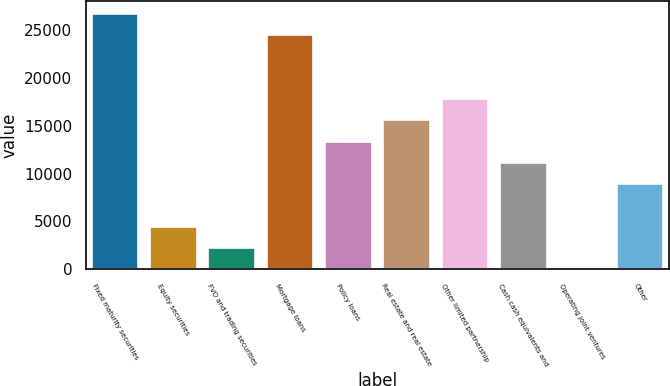<chart> <loc_0><loc_0><loc_500><loc_500><bar_chart><fcel>Fixed maturity securities<fcel>Equity securities<fcel>FVO and trading securities<fcel>Mortgage loans<fcel>Policy loans<fcel>Real estate and real estate<fcel>Other limited partnership<fcel>Cash cash equivalents and<fcel>Operating joint ventures<fcel>Other<nl><fcel>26676.4<fcel>4454.4<fcel>2232.2<fcel>24454.2<fcel>13343.2<fcel>15565.4<fcel>17787.6<fcel>11121<fcel>10<fcel>8898.8<nl></chart> 